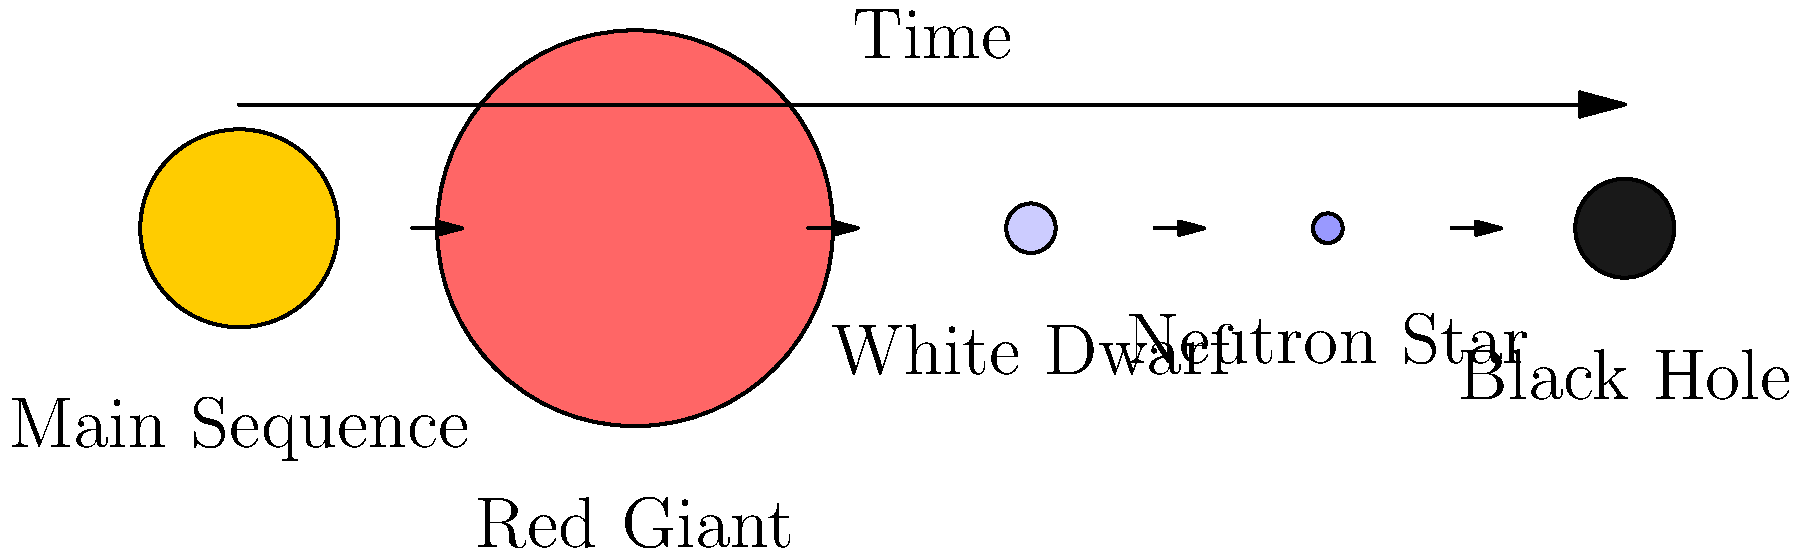In the context of stellar evolution, which stage of a star's life cycle is most closely related to the concept of "fusion" in music, where different elements come together to create something new? Explain your reasoning using the diagram provided. To answer this question, let's break down the stages of stellar evolution shown in the diagram and relate them to the concept of fusion in music:

1. Main Sequence: This is the longest stage of a star's life, where hydrogen is fused into helium in the core. This stage is relatively stable and could be compared to a standard musical genre.

2. Red Giant: As the hydrogen in the core is depleted, the star expands and cools. Fusion continues in a shell around the core, and eventually, helium fusion begins in the core. This stage involves new types of fusion, similar to how fusion in music combines different genres.

3. White Dwarf: At this stage, fusion has stopped, and the star is cooling down. This is less related to musical fusion.

4. Neutron Star: This is a collapsed remnant of a massive star. No fusion occurs at this stage.

5. Black Hole: This is the final stage for very massive stars. No fusion occurs here either.

The stage that most closely relates to the concept of fusion in music is the Red Giant stage. Here's why:

1. New elements: In the Red Giant stage, the star begins fusing helium into heavier elements like carbon and oxygen. This is similar to how fusion in music brings together different musical elements or genres.

2. Expansion and change: The star dramatically changes its structure and appearance, just as fusion in music often leads to new and expanded musical forms.

3. Creative process: The Red Giant stage represents a creative turning point in the star's life, where new processes occur. This mirrors how musical fusion often leads to creative breakthroughs and new genres.

4. Bridging stages: The Red Giant stage bridges the Main Sequence and later stages, just as musical fusion often serves as a bridge between traditional and new forms of music.
Answer: Red Giant stage 